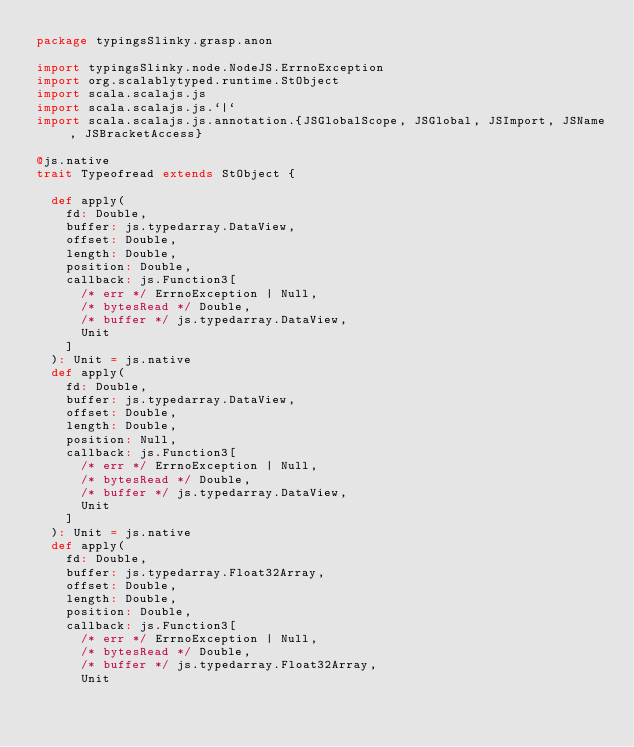<code> <loc_0><loc_0><loc_500><loc_500><_Scala_>package typingsSlinky.grasp.anon

import typingsSlinky.node.NodeJS.ErrnoException
import org.scalablytyped.runtime.StObject
import scala.scalajs.js
import scala.scalajs.js.`|`
import scala.scalajs.js.annotation.{JSGlobalScope, JSGlobal, JSImport, JSName, JSBracketAccess}

@js.native
trait Typeofread extends StObject {
  
  def apply(
    fd: Double,
    buffer: js.typedarray.DataView,
    offset: Double,
    length: Double,
    position: Double,
    callback: js.Function3[
      /* err */ ErrnoException | Null, 
      /* bytesRead */ Double, 
      /* buffer */ js.typedarray.DataView, 
      Unit
    ]
  ): Unit = js.native
  def apply(
    fd: Double,
    buffer: js.typedarray.DataView,
    offset: Double,
    length: Double,
    position: Null,
    callback: js.Function3[
      /* err */ ErrnoException | Null, 
      /* bytesRead */ Double, 
      /* buffer */ js.typedarray.DataView, 
      Unit
    ]
  ): Unit = js.native
  def apply(
    fd: Double,
    buffer: js.typedarray.Float32Array,
    offset: Double,
    length: Double,
    position: Double,
    callback: js.Function3[
      /* err */ ErrnoException | Null, 
      /* bytesRead */ Double, 
      /* buffer */ js.typedarray.Float32Array, 
      Unit</code> 